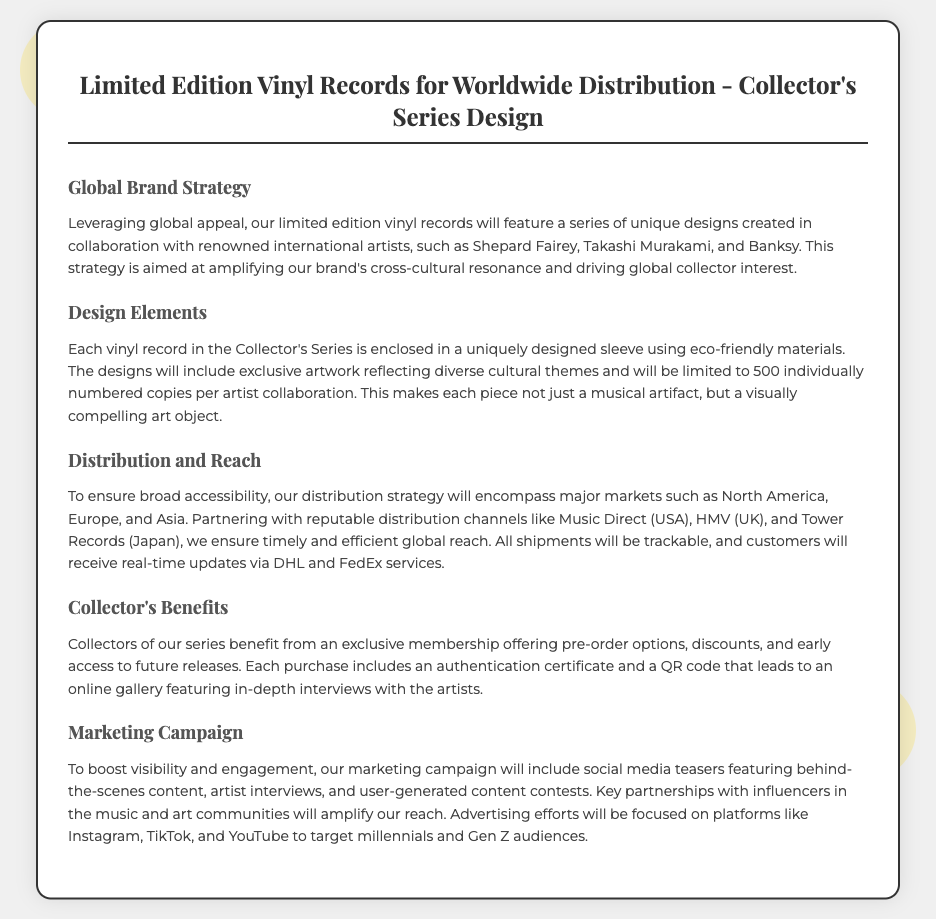What is the title of the document? The title of the document prominently displays the subject matter related to the product being shipped.
Answer: Limited Edition Vinyl Records - Shipping Label How many copies are produced per artist collaboration? The document states that each design will have a limitation on the number of copies produced, emphasizing exclusivity and collectibility.
Answer: 500 Who are some of the renowned artists involved? The document lists notable artists whose artwork will be featured, showcasing the collaboration's prestige and appeal.
Answer: Shepard Fairey, Takashi Murakami, Banksy What is the primary distribution partner mentioned for the USA? The document specifies a prominent distribution partner to ensure accessibility in a key market, lending credibility to the distribution strategy.
Answer: Music Direct What certification is included with each purchase? This document highlights an essential benefit associated with each purchase that adds value for collectors, enhancing authenticity.
Answer: Authentication certificate Which social media platforms are targeted for advertising? The document mentions specific platforms where the marketing campaign will focus to reach younger audiences effectively.
Answer: Instagram, TikTok, YouTube What type of materials are used for the record sleeves? The document describes a commitment to sustainability by indicating the type of materials used for the product packaging.
Answer: Eco-friendly materials What benefit do collectors receive regarding future releases? The document outlines a key advantage for collectors, encouraging engagement and loyalty through exclusive offers.
Answer: Early access 